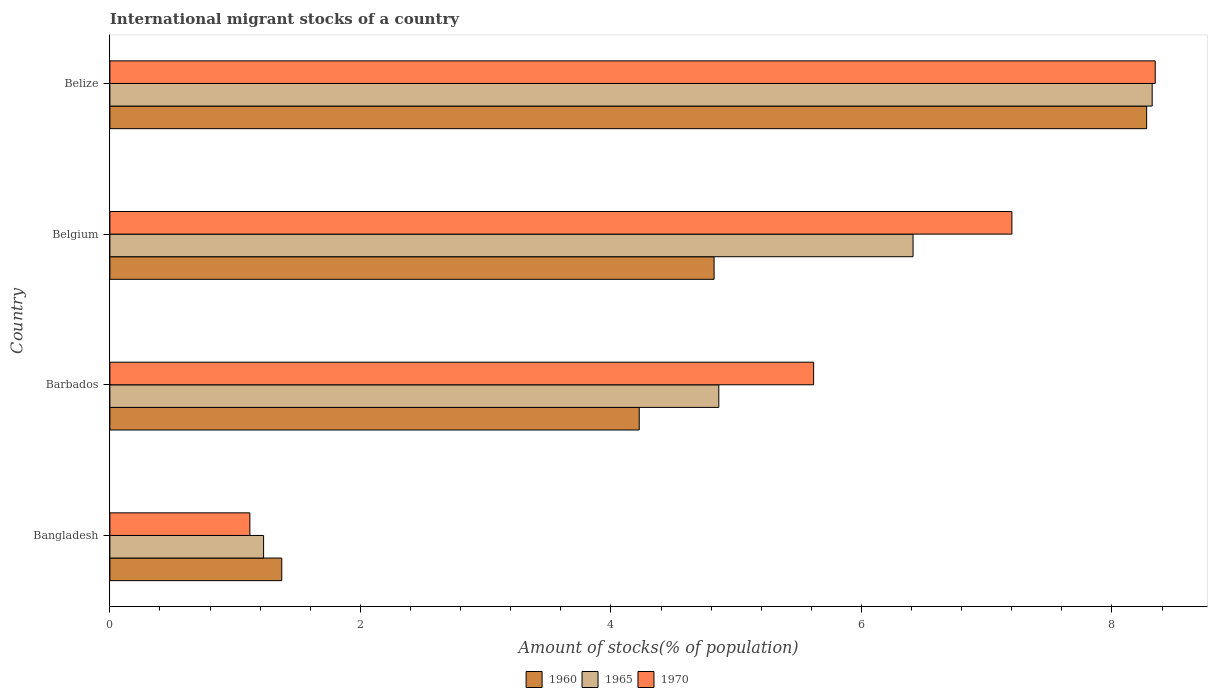Are the number of bars per tick equal to the number of legend labels?
Your answer should be very brief. Yes. Are the number of bars on each tick of the Y-axis equal?
Make the answer very short. Yes. How many bars are there on the 1st tick from the bottom?
Keep it short and to the point. 3. What is the label of the 1st group of bars from the top?
Your answer should be compact. Belize. What is the amount of stocks in in 1970 in Bangladesh?
Ensure brevity in your answer.  1.12. Across all countries, what is the maximum amount of stocks in in 1970?
Offer a very short reply. 8.35. Across all countries, what is the minimum amount of stocks in in 1970?
Your answer should be very brief. 1.12. In which country was the amount of stocks in in 1970 maximum?
Your answer should be compact. Belize. What is the total amount of stocks in in 1960 in the graph?
Ensure brevity in your answer.  18.7. What is the difference between the amount of stocks in in 1965 in Barbados and that in Belgium?
Offer a very short reply. -1.55. What is the difference between the amount of stocks in in 1960 in Belize and the amount of stocks in in 1970 in Barbados?
Give a very brief answer. 2.66. What is the average amount of stocks in in 1970 per country?
Offer a terse response. 5.57. What is the difference between the amount of stocks in in 1970 and amount of stocks in in 1960 in Belgium?
Ensure brevity in your answer.  2.38. What is the ratio of the amount of stocks in in 1970 in Bangladesh to that in Belize?
Your response must be concise. 0.13. Is the amount of stocks in in 1960 in Bangladesh less than that in Belize?
Offer a very short reply. Yes. What is the difference between the highest and the second highest amount of stocks in in 1970?
Your answer should be compact. 1.14. What is the difference between the highest and the lowest amount of stocks in in 1965?
Your answer should be very brief. 7.09. Is the sum of the amount of stocks in in 1960 in Barbados and Belgium greater than the maximum amount of stocks in in 1970 across all countries?
Your answer should be very brief. Yes. What does the 1st bar from the top in Belize represents?
Provide a short and direct response. 1970. What does the 2nd bar from the bottom in Belize represents?
Your response must be concise. 1965. Is it the case that in every country, the sum of the amount of stocks in in 1970 and amount of stocks in in 1960 is greater than the amount of stocks in in 1965?
Provide a succinct answer. Yes. How many countries are there in the graph?
Make the answer very short. 4. What is the difference between two consecutive major ticks on the X-axis?
Give a very brief answer. 2. What is the title of the graph?
Your answer should be compact. International migrant stocks of a country. What is the label or title of the X-axis?
Your answer should be compact. Amount of stocks(% of population). What is the label or title of the Y-axis?
Your answer should be compact. Country. What is the Amount of stocks(% of population) of 1960 in Bangladesh?
Provide a succinct answer. 1.37. What is the Amount of stocks(% of population) of 1965 in Bangladesh?
Give a very brief answer. 1.23. What is the Amount of stocks(% of population) in 1970 in Bangladesh?
Your answer should be very brief. 1.12. What is the Amount of stocks(% of population) of 1960 in Barbados?
Offer a very short reply. 4.23. What is the Amount of stocks(% of population) of 1965 in Barbados?
Give a very brief answer. 4.86. What is the Amount of stocks(% of population) in 1970 in Barbados?
Offer a terse response. 5.62. What is the Amount of stocks(% of population) of 1960 in Belgium?
Provide a short and direct response. 4.82. What is the Amount of stocks(% of population) in 1965 in Belgium?
Ensure brevity in your answer.  6.41. What is the Amount of stocks(% of population) of 1970 in Belgium?
Offer a terse response. 7.2. What is the Amount of stocks(% of population) in 1960 in Belize?
Provide a short and direct response. 8.28. What is the Amount of stocks(% of population) of 1965 in Belize?
Your answer should be compact. 8.32. What is the Amount of stocks(% of population) of 1970 in Belize?
Offer a very short reply. 8.35. Across all countries, what is the maximum Amount of stocks(% of population) in 1960?
Make the answer very short. 8.28. Across all countries, what is the maximum Amount of stocks(% of population) in 1965?
Make the answer very short. 8.32. Across all countries, what is the maximum Amount of stocks(% of population) of 1970?
Your answer should be compact. 8.35. Across all countries, what is the minimum Amount of stocks(% of population) in 1960?
Provide a short and direct response. 1.37. Across all countries, what is the minimum Amount of stocks(% of population) of 1965?
Provide a succinct answer. 1.23. Across all countries, what is the minimum Amount of stocks(% of population) in 1970?
Keep it short and to the point. 1.12. What is the total Amount of stocks(% of population) in 1960 in the graph?
Ensure brevity in your answer.  18.7. What is the total Amount of stocks(% of population) of 1965 in the graph?
Provide a short and direct response. 20.82. What is the total Amount of stocks(% of population) of 1970 in the graph?
Give a very brief answer. 22.28. What is the difference between the Amount of stocks(% of population) in 1960 in Bangladesh and that in Barbados?
Keep it short and to the point. -2.85. What is the difference between the Amount of stocks(% of population) of 1965 in Bangladesh and that in Barbados?
Offer a very short reply. -3.63. What is the difference between the Amount of stocks(% of population) in 1970 in Bangladesh and that in Barbados?
Your answer should be very brief. -4.5. What is the difference between the Amount of stocks(% of population) of 1960 in Bangladesh and that in Belgium?
Give a very brief answer. -3.45. What is the difference between the Amount of stocks(% of population) of 1965 in Bangladesh and that in Belgium?
Make the answer very short. -5.19. What is the difference between the Amount of stocks(% of population) in 1970 in Bangladesh and that in Belgium?
Offer a very short reply. -6.08. What is the difference between the Amount of stocks(% of population) in 1960 in Bangladesh and that in Belize?
Your answer should be very brief. -6.91. What is the difference between the Amount of stocks(% of population) in 1965 in Bangladesh and that in Belize?
Ensure brevity in your answer.  -7.09. What is the difference between the Amount of stocks(% of population) in 1970 in Bangladesh and that in Belize?
Offer a very short reply. -7.23. What is the difference between the Amount of stocks(% of population) of 1960 in Barbados and that in Belgium?
Keep it short and to the point. -0.6. What is the difference between the Amount of stocks(% of population) in 1965 in Barbados and that in Belgium?
Give a very brief answer. -1.55. What is the difference between the Amount of stocks(% of population) of 1970 in Barbados and that in Belgium?
Make the answer very short. -1.58. What is the difference between the Amount of stocks(% of population) in 1960 in Barbados and that in Belize?
Offer a very short reply. -4.05. What is the difference between the Amount of stocks(% of population) in 1965 in Barbados and that in Belize?
Your answer should be compact. -3.46. What is the difference between the Amount of stocks(% of population) in 1970 in Barbados and that in Belize?
Keep it short and to the point. -2.73. What is the difference between the Amount of stocks(% of population) of 1960 in Belgium and that in Belize?
Your response must be concise. -3.45. What is the difference between the Amount of stocks(% of population) in 1965 in Belgium and that in Belize?
Ensure brevity in your answer.  -1.91. What is the difference between the Amount of stocks(% of population) in 1970 in Belgium and that in Belize?
Your answer should be very brief. -1.14. What is the difference between the Amount of stocks(% of population) of 1960 in Bangladesh and the Amount of stocks(% of population) of 1965 in Barbados?
Offer a very short reply. -3.49. What is the difference between the Amount of stocks(% of population) in 1960 in Bangladesh and the Amount of stocks(% of population) in 1970 in Barbados?
Offer a very short reply. -4.25. What is the difference between the Amount of stocks(% of population) in 1965 in Bangladesh and the Amount of stocks(% of population) in 1970 in Barbados?
Your answer should be very brief. -4.39. What is the difference between the Amount of stocks(% of population) in 1960 in Bangladesh and the Amount of stocks(% of population) in 1965 in Belgium?
Provide a succinct answer. -5.04. What is the difference between the Amount of stocks(% of population) of 1960 in Bangladesh and the Amount of stocks(% of population) of 1970 in Belgium?
Offer a very short reply. -5.83. What is the difference between the Amount of stocks(% of population) of 1965 in Bangladesh and the Amount of stocks(% of population) of 1970 in Belgium?
Your response must be concise. -5.97. What is the difference between the Amount of stocks(% of population) in 1960 in Bangladesh and the Amount of stocks(% of population) in 1965 in Belize?
Give a very brief answer. -6.95. What is the difference between the Amount of stocks(% of population) of 1960 in Bangladesh and the Amount of stocks(% of population) of 1970 in Belize?
Your answer should be very brief. -6.97. What is the difference between the Amount of stocks(% of population) in 1965 in Bangladesh and the Amount of stocks(% of population) in 1970 in Belize?
Your answer should be very brief. -7.12. What is the difference between the Amount of stocks(% of population) in 1960 in Barbados and the Amount of stocks(% of population) in 1965 in Belgium?
Give a very brief answer. -2.19. What is the difference between the Amount of stocks(% of population) of 1960 in Barbados and the Amount of stocks(% of population) of 1970 in Belgium?
Offer a very short reply. -2.98. What is the difference between the Amount of stocks(% of population) of 1965 in Barbados and the Amount of stocks(% of population) of 1970 in Belgium?
Offer a terse response. -2.34. What is the difference between the Amount of stocks(% of population) in 1960 in Barbados and the Amount of stocks(% of population) in 1965 in Belize?
Make the answer very short. -4.1. What is the difference between the Amount of stocks(% of population) of 1960 in Barbados and the Amount of stocks(% of population) of 1970 in Belize?
Provide a succinct answer. -4.12. What is the difference between the Amount of stocks(% of population) in 1965 in Barbados and the Amount of stocks(% of population) in 1970 in Belize?
Provide a short and direct response. -3.48. What is the difference between the Amount of stocks(% of population) in 1960 in Belgium and the Amount of stocks(% of population) in 1965 in Belize?
Give a very brief answer. -3.5. What is the difference between the Amount of stocks(% of population) of 1960 in Belgium and the Amount of stocks(% of population) of 1970 in Belize?
Provide a succinct answer. -3.52. What is the difference between the Amount of stocks(% of population) in 1965 in Belgium and the Amount of stocks(% of population) in 1970 in Belize?
Give a very brief answer. -1.93. What is the average Amount of stocks(% of population) in 1960 per country?
Make the answer very short. 4.67. What is the average Amount of stocks(% of population) of 1965 per country?
Provide a succinct answer. 5.21. What is the average Amount of stocks(% of population) of 1970 per country?
Your response must be concise. 5.57. What is the difference between the Amount of stocks(% of population) of 1960 and Amount of stocks(% of population) of 1965 in Bangladesh?
Offer a very short reply. 0.15. What is the difference between the Amount of stocks(% of population) in 1960 and Amount of stocks(% of population) in 1970 in Bangladesh?
Give a very brief answer. 0.25. What is the difference between the Amount of stocks(% of population) of 1965 and Amount of stocks(% of population) of 1970 in Bangladesh?
Your answer should be very brief. 0.11. What is the difference between the Amount of stocks(% of population) of 1960 and Amount of stocks(% of population) of 1965 in Barbados?
Make the answer very short. -0.64. What is the difference between the Amount of stocks(% of population) of 1960 and Amount of stocks(% of population) of 1970 in Barbados?
Offer a terse response. -1.39. What is the difference between the Amount of stocks(% of population) in 1965 and Amount of stocks(% of population) in 1970 in Barbados?
Keep it short and to the point. -0.76. What is the difference between the Amount of stocks(% of population) in 1960 and Amount of stocks(% of population) in 1965 in Belgium?
Provide a short and direct response. -1.59. What is the difference between the Amount of stocks(% of population) of 1960 and Amount of stocks(% of population) of 1970 in Belgium?
Your answer should be compact. -2.38. What is the difference between the Amount of stocks(% of population) in 1965 and Amount of stocks(% of population) in 1970 in Belgium?
Provide a succinct answer. -0.79. What is the difference between the Amount of stocks(% of population) in 1960 and Amount of stocks(% of population) in 1965 in Belize?
Offer a terse response. -0.04. What is the difference between the Amount of stocks(% of population) in 1960 and Amount of stocks(% of population) in 1970 in Belize?
Your answer should be compact. -0.07. What is the difference between the Amount of stocks(% of population) of 1965 and Amount of stocks(% of population) of 1970 in Belize?
Provide a succinct answer. -0.02. What is the ratio of the Amount of stocks(% of population) in 1960 in Bangladesh to that in Barbados?
Your answer should be very brief. 0.32. What is the ratio of the Amount of stocks(% of population) of 1965 in Bangladesh to that in Barbados?
Offer a very short reply. 0.25. What is the ratio of the Amount of stocks(% of population) of 1970 in Bangladesh to that in Barbados?
Your answer should be very brief. 0.2. What is the ratio of the Amount of stocks(% of population) in 1960 in Bangladesh to that in Belgium?
Keep it short and to the point. 0.28. What is the ratio of the Amount of stocks(% of population) of 1965 in Bangladesh to that in Belgium?
Keep it short and to the point. 0.19. What is the ratio of the Amount of stocks(% of population) of 1970 in Bangladesh to that in Belgium?
Provide a short and direct response. 0.16. What is the ratio of the Amount of stocks(% of population) of 1960 in Bangladesh to that in Belize?
Offer a very short reply. 0.17. What is the ratio of the Amount of stocks(% of population) in 1965 in Bangladesh to that in Belize?
Make the answer very short. 0.15. What is the ratio of the Amount of stocks(% of population) of 1970 in Bangladesh to that in Belize?
Offer a very short reply. 0.13. What is the ratio of the Amount of stocks(% of population) of 1960 in Barbados to that in Belgium?
Provide a succinct answer. 0.88. What is the ratio of the Amount of stocks(% of population) in 1965 in Barbados to that in Belgium?
Keep it short and to the point. 0.76. What is the ratio of the Amount of stocks(% of population) in 1970 in Barbados to that in Belgium?
Offer a very short reply. 0.78. What is the ratio of the Amount of stocks(% of population) in 1960 in Barbados to that in Belize?
Provide a succinct answer. 0.51. What is the ratio of the Amount of stocks(% of population) of 1965 in Barbados to that in Belize?
Your answer should be compact. 0.58. What is the ratio of the Amount of stocks(% of population) of 1970 in Barbados to that in Belize?
Your answer should be compact. 0.67. What is the ratio of the Amount of stocks(% of population) in 1960 in Belgium to that in Belize?
Keep it short and to the point. 0.58. What is the ratio of the Amount of stocks(% of population) of 1965 in Belgium to that in Belize?
Ensure brevity in your answer.  0.77. What is the ratio of the Amount of stocks(% of population) of 1970 in Belgium to that in Belize?
Provide a succinct answer. 0.86. What is the difference between the highest and the second highest Amount of stocks(% of population) of 1960?
Provide a short and direct response. 3.45. What is the difference between the highest and the second highest Amount of stocks(% of population) in 1965?
Your response must be concise. 1.91. What is the difference between the highest and the second highest Amount of stocks(% of population) in 1970?
Your answer should be compact. 1.14. What is the difference between the highest and the lowest Amount of stocks(% of population) in 1960?
Offer a terse response. 6.91. What is the difference between the highest and the lowest Amount of stocks(% of population) in 1965?
Provide a short and direct response. 7.09. What is the difference between the highest and the lowest Amount of stocks(% of population) in 1970?
Offer a very short reply. 7.23. 